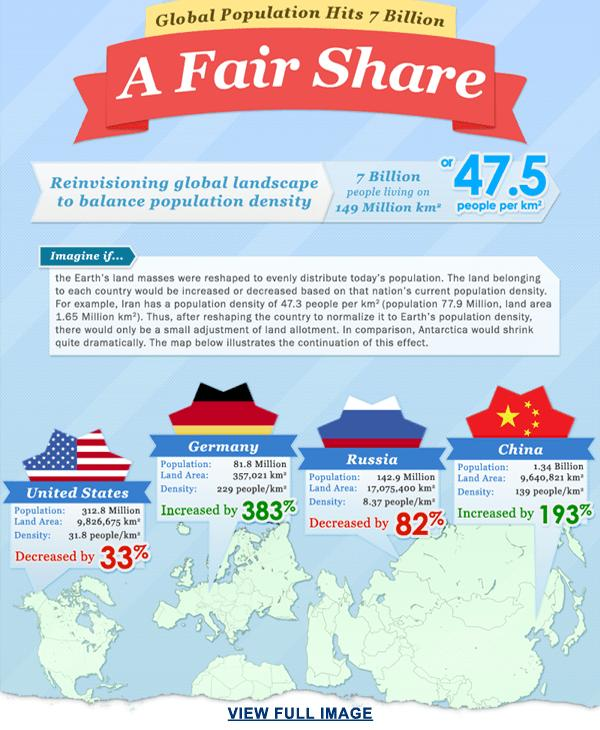Specify some key components in this picture. Russia has the highest percentage decrease in population among all countries. Germany has the highest percentage increase in population among all countries. 